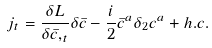Convert formula to latex. <formula><loc_0><loc_0><loc_500><loc_500>j _ { t } = \frac { \delta L } { \delta \bar { c } , _ { t } } \delta \bar { c } - \frac { i } { 2 } \bar { c } ^ { a } \delta _ { 2 } c ^ { a } + h . c .</formula> 